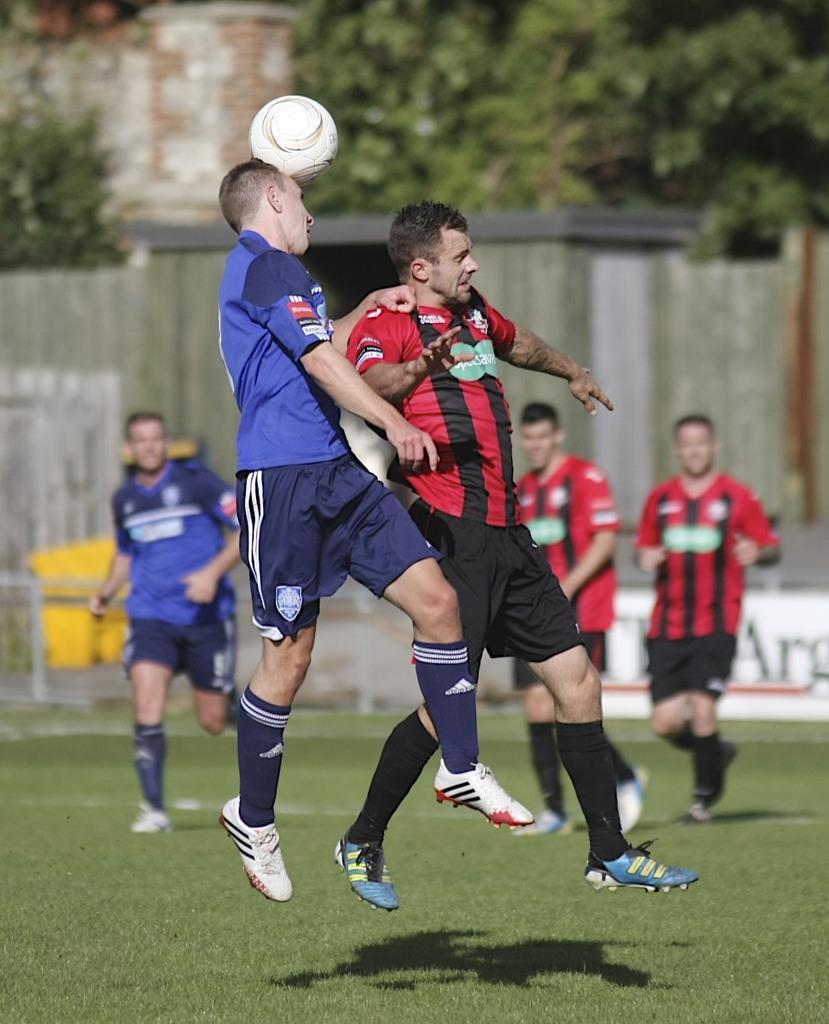Describe this image in one or two sentences. In this image, There is grass on the ground and there are some people playing the football and in the background there are walls made of bricks. 